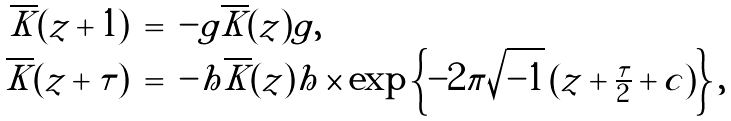<formula> <loc_0><loc_0><loc_500><loc_500>\begin{array} { r c l } \overline { K } ( z + 1 ) & = & - g \overline { K } ( z ) g , \\ \overline { K } ( z + \tau ) & = & - h \overline { K } ( z ) h \times \exp \left \{ - 2 \pi \sqrt { - 1 } \left ( z + \frac { \tau } { 2 } + c \right ) \right \} , \end{array}</formula> 